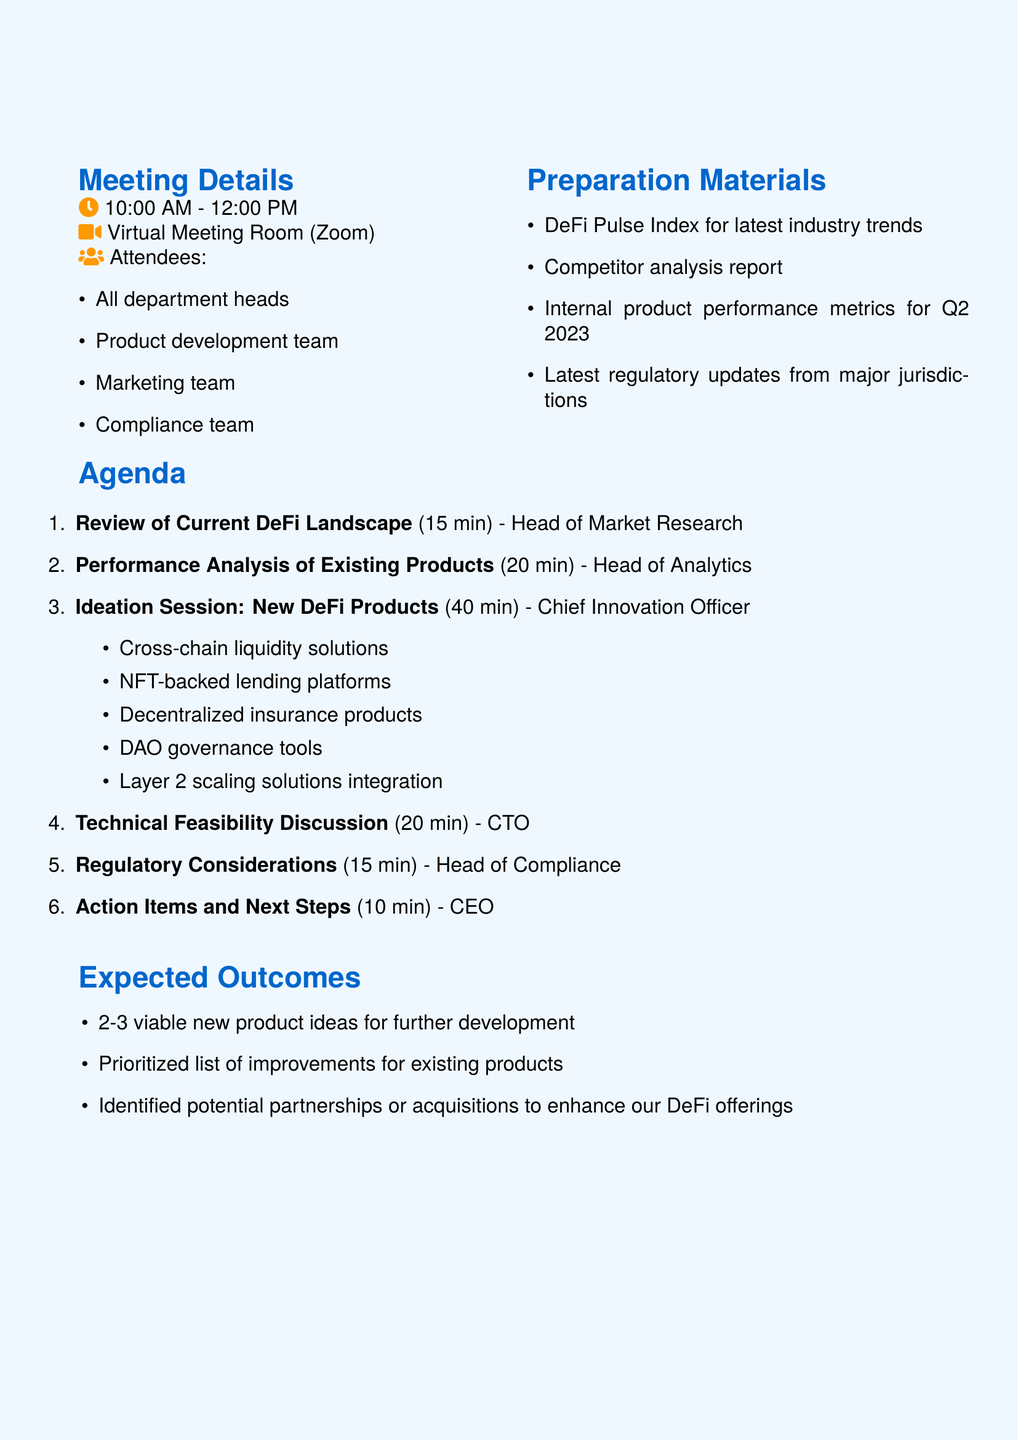what is the date of the meeting? The document clearly states the date of the meeting as June 15, 2023.
Answer: June 15, 2023 who is the presenter for the performance analysis? The document lists the presenter for this item as the Head of Analytics.
Answer: Head of Analytics how long is the ideation session scheduled for? The agenda specifies that the ideation session is allocated 40 minutes.
Answer: 40 minutes what topic is covered in the regulatory considerations? The document describes the regulatory considerations focusing on recent SEC statements and EU's MiCA regulation.
Answer: Recent SEC statements and EU's MiCA regulation which team facilitates the action items and next steps? The document mentions that the CEO facilitates the action items and next steps.
Answer: CEO what is one expected outcome of the brainstorming session? The expected outcomes list includes identifying 2-3 viable new product ideas for further development.
Answer: 2-3 viable new product ideas how many attendees are listed for the meeting? The document outlines that the attendees include all department heads, the product development team, the marketing team, and the compliance team.
Answer: Four teams what is a suggested topic for the ideation session? The document provides several potential topics, such as cross-chain liquidity solutions or NFT-backed lending platforms.
Answer: Cross-chain liquidity solutions what is the meeting duration? The document specifies that the meeting is scheduled to last from 10:00 AM to 12:00 PM, which is a total of 2 hours.
Answer: 2 hours 